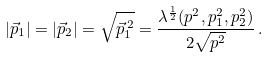<formula> <loc_0><loc_0><loc_500><loc_500>| \vec { p } _ { 1 } | = | \vec { p } _ { 2 } | = \sqrt { \vec { p } _ { 1 } ^ { \, 2 } } = \frac { \lambda ^ { \frac { 1 } { 2 } } ( p ^ { 2 } , p _ { 1 } ^ { 2 } , p _ { 2 } ^ { 2 } ) } { 2 \sqrt { p ^ { 2 } } } \, .</formula> 